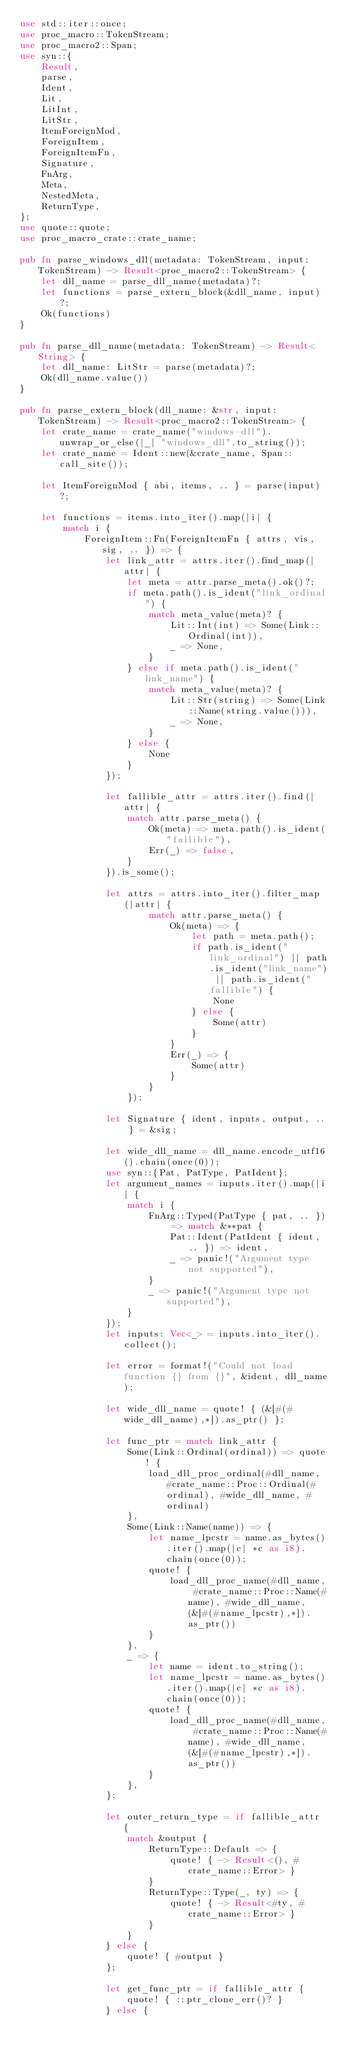Convert code to text. <code><loc_0><loc_0><loc_500><loc_500><_Rust_>use std::iter::once;
use proc_macro::TokenStream;
use proc_macro2::Span;
use syn::{
    Result,
    parse,
    Ident,
    Lit,
    LitInt,
    LitStr,
    ItemForeignMod,
    ForeignItem,
    ForeignItemFn,
    Signature,
    FnArg,
    Meta,
    NestedMeta,
    ReturnType,
};
use quote::quote;
use proc_macro_crate::crate_name;

pub fn parse_windows_dll(metadata: TokenStream, input: TokenStream) -> Result<proc_macro2::TokenStream> {
    let dll_name = parse_dll_name(metadata)?;
    let functions = parse_extern_block(&dll_name, input)?;
    Ok(functions)
}

pub fn parse_dll_name(metadata: TokenStream) -> Result<String> {
    let dll_name: LitStr = parse(metadata)?;
    Ok(dll_name.value())
}

pub fn parse_extern_block(dll_name: &str, input: TokenStream) -> Result<proc_macro2::TokenStream> {
    let crate_name = crate_name("windows-dll").unwrap_or_else(|_| "windows_dll".to_string());
    let crate_name = Ident::new(&crate_name, Span::call_site());

    let ItemForeignMod { abi, items, .. } = parse(input)?;

    let functions = items.into_iter().map(|i| {
        match i {
            ForeignItem::Fn(ForeignItemFn { attrs, vis, sig, .. }) => {
                let link_attr = attrs.iter().find_map(|attr| {
                    let meta = attr.parse_meta().ok()?;
                    if meta.path().is_ident("link_ordinal") {
                        match meta_value(meta)? {
                            Lit::Int(int) => Some(Link::Ordinal(int)),
                            _ => None,
                        }
                    } else if meta.path().is_ident("link_name") {
                        match meta_value(meta)? {
                            Lit::Str(string) => Some(Link::Name(string.value())),
                            _ => None,
                        }
                    } else {
                        None
                    }
                });

                let fallible_attr = attrs.iter().find(|attr| {
                    match attr.parse_meta() {
                        Ok(meta) => meta.path().is_ident("fallible"),
                        Err(_) => false,
                    }
                }).is_some();

                let attrs = attrs.into_iter().filter_map(|attr| {
                        match attr.parse_meta() {
                            Ok(meta) => {
                                let path = meta.path();
                                if path.is_ident("link_ordinal") || path.is_ident("link_name") || path.is_ident("fallible") {
                                    None
                                } else {
                                    Some(attr)
                                }
                            }
                            Err(_) => {
                                Some(attr)
                            }
                        }
                    });

                let Signature { ident, inputs, output, .. } = &sig;

                let wide_dll_name = dll_name.encode_utf16().chain(once(0));
                use syn::{Pat, PatType, PatIdent};
                let argument_names = inputs.iter().map(|i| {
                    match i {
                        FnArg::Typed(PatType { pat, .. }) => match &**pat {
                            Pat::Ident(PatIdent { ident, .. }) => ident,
                            _ => panic!("Argument type not supported"),
                        }
                        _ => panic!("Argument type not supported"),
                    }
                });
                let inputs: Vec<_> = inputs.into_iter().collect();

                let error = format!("Could not load function {} from {}", &ident, dll_name);

                let wide_dll_name = quote! { (&[#(#wide_dll_name),*]).as_ptr() };

                let func_ptr = match link_attr {
                    Some(Link::Ordinal(ordinal)) => quote! {
                        load_dll_proc_ordinal(#dll_name, #crate_name::Proc::Ordinal(#ordinal), #wide_dll_name, #ordinal)
                    },
                    Some(Link::Name(name)) => {
                        let name_lpcstr = name.as_bytes().iter().map(|c| *c as i8).chain(once(0));
                        quote! {
                            load_dll_proc_name(#dll_name, #crate_name::Proc::Name(#name), #wide_dll_name, (&[#(#name_lpcstr),*]).as_ptr())
                        }
                    },
                    _ => {
                        let name = ident.to_string();
                        let name_lpcstr = name.as_bytes().iter().map(|c| *c as i8).chain(once(0));
                        quote! {
                            load_dll_proc_name(#dll_name, #crate_name::Proc::Name(#name), #wide_dll_name, (&[#(#name_lpcstr),*]).as_ptr())
                        }
                    },
                };

                let outer_return_type = if fallible_attr {
                    match &output {
                        ReturnType::Default => {
                            quote! { -> Result<(), #crate_name::Error> }
                        }
                        ReturnType::Type(_, ty) => {
                            quote! { -> Result<#ty, #crate_name::Error> }
                        }
                    }
                } else {
                    quote! { #output }
                };

                let get_func_ptr = if fallible_attr {
                    quote! { ::ptr_clone_err()? }
                } else {</code> 